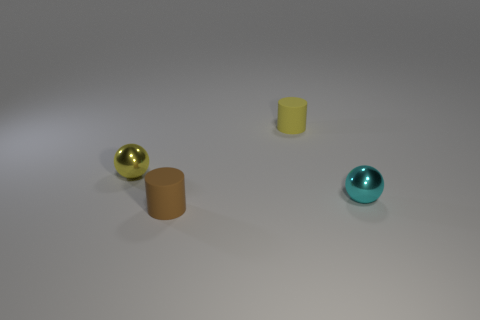Add 3 gray metal things. How many objects exist? 7 Add 4 cyan metallic objects. How many cyan metallic objects exist? 5 Subtract 0 green cubes. How many objects are left? 4 Subtract all balls. Subtract all yellow balls. How many objects are left? 1 Add 2 matte objects. How many matte objects are left? 4 